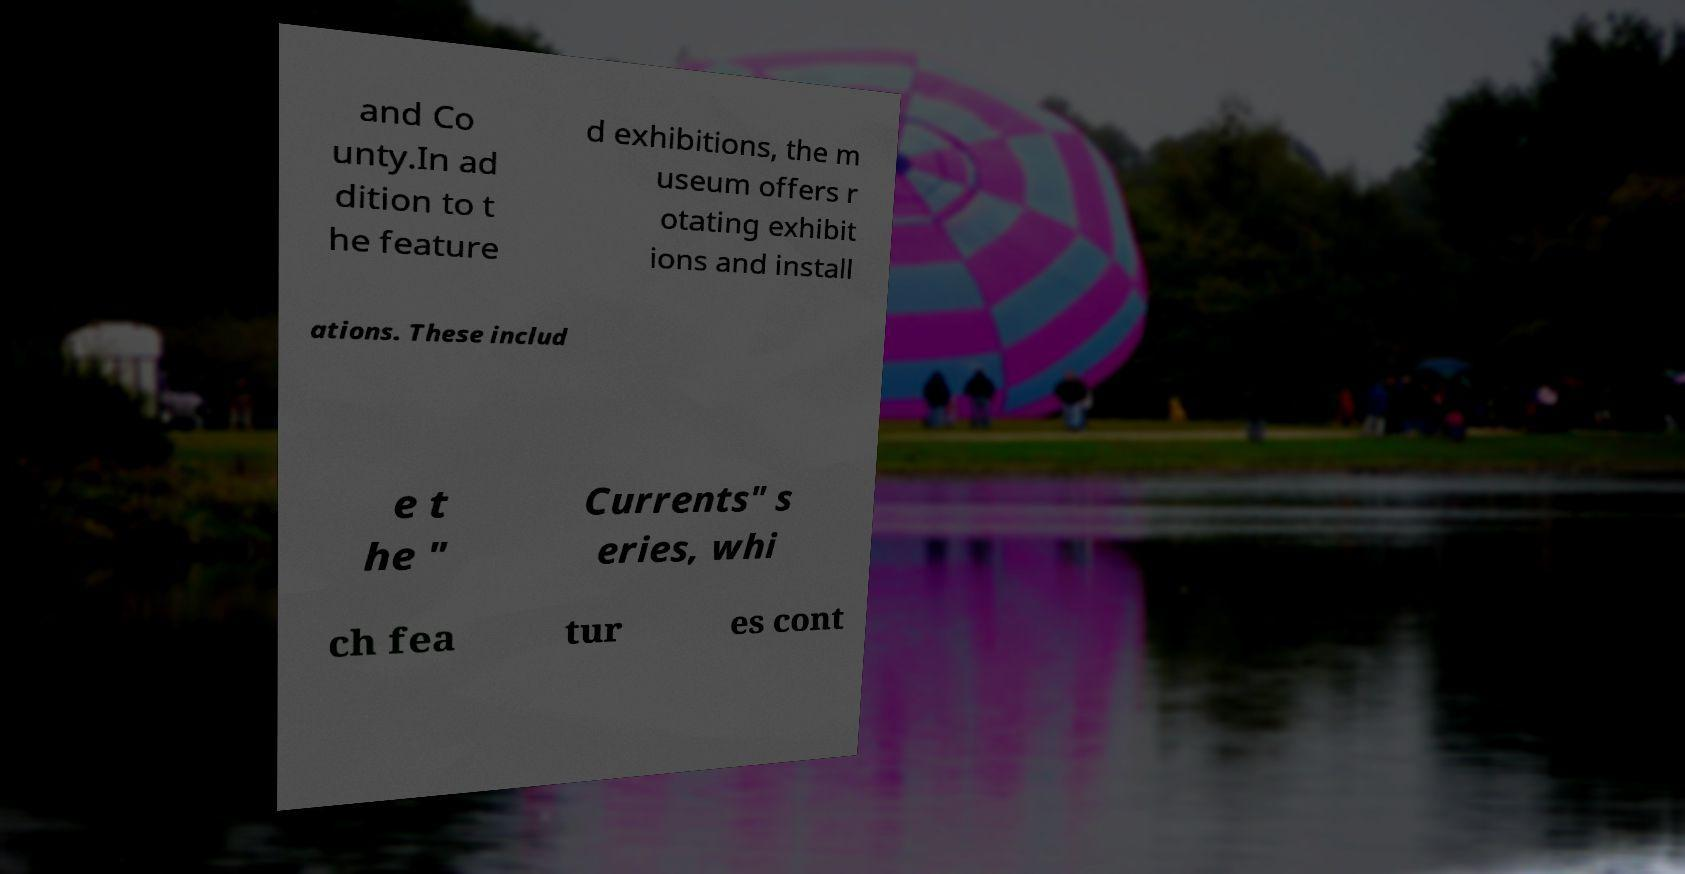Please read and relay the text visible in this image. What does it say? and Co unty.In ad dition to t he feature d exhibitions, the m useum offers r otating exhibit ions and install ations. These includ e t he " Currents" s eries, whi ch fea tur es cont 